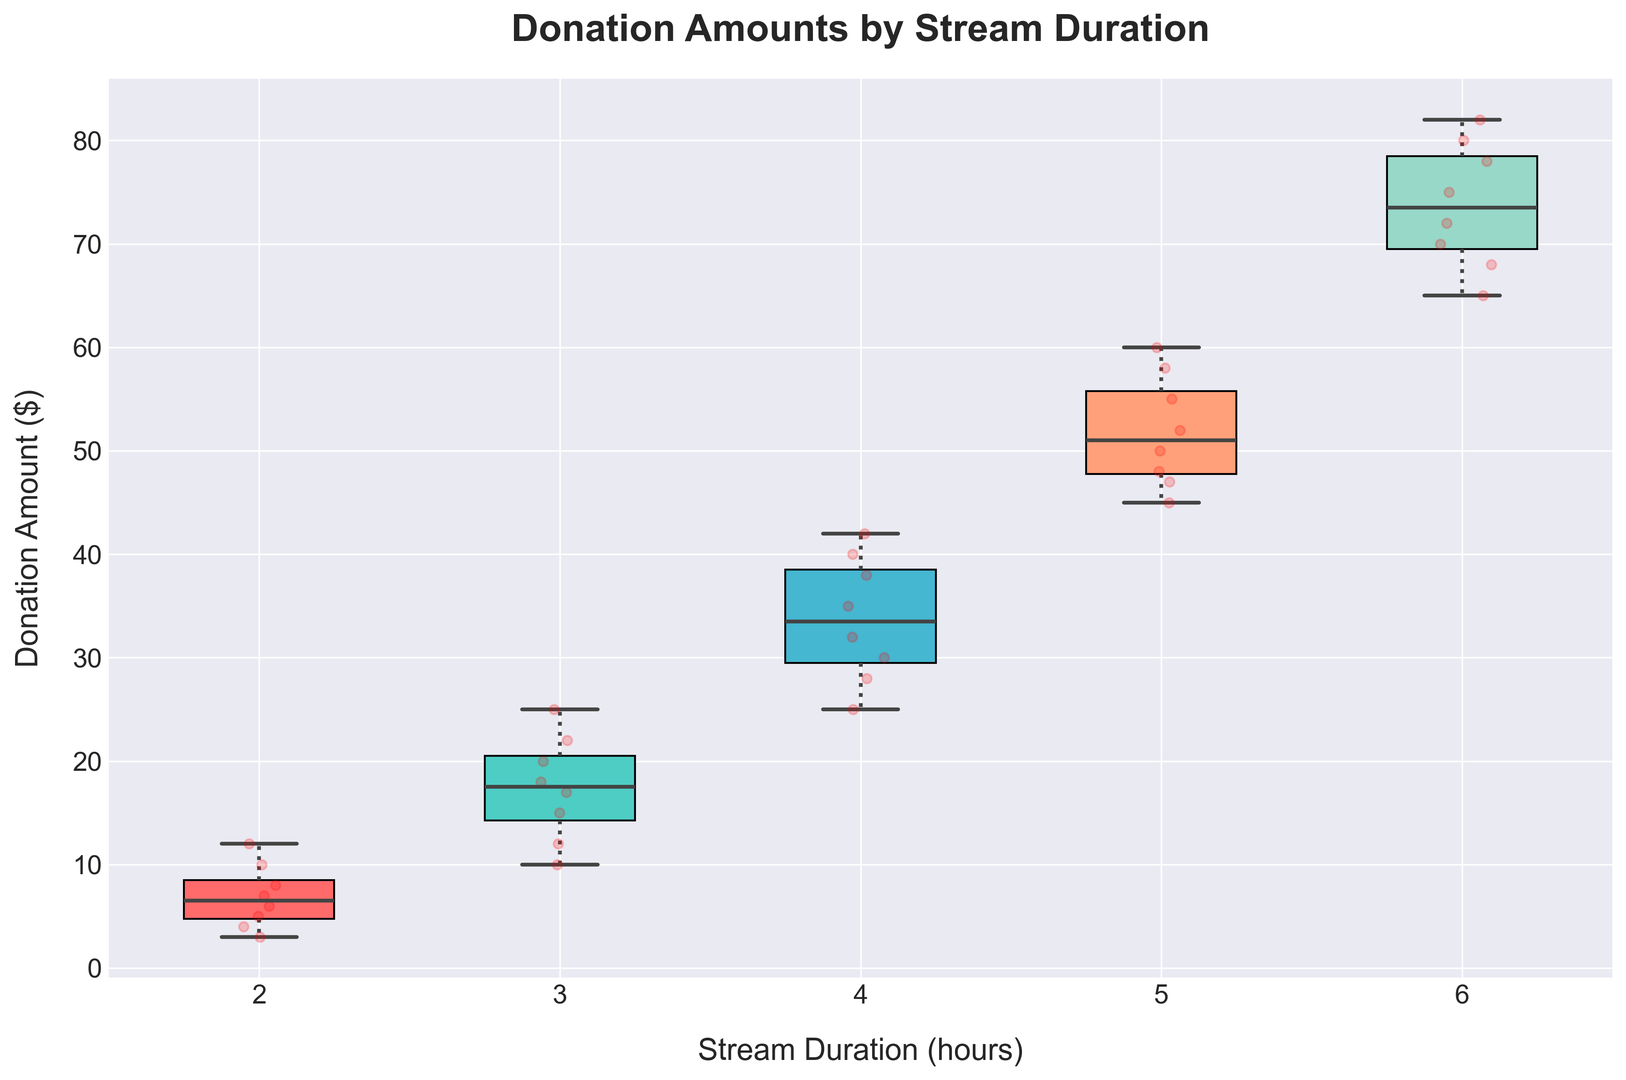What's the median donation amount for 4-hour streams? To find the median, locate the middle value when the donation amounts are arranged in ascending order. For 4-hour streams, the donations are 25, 28, 30, 32, 35, 38, 40, 42. The middle values are 32 and 35, so the median is (32 + 35) / 2 = 33.5.
Answer: 33.5 Which stream duration has the highest maximum donation amount? Examine the upper whisker of each box plot to identify the maximum donation amount for each stream duration. The 6-hour stream duration has the highest maximum donation amount, which is 82.
Answer: 6-hour What is the range of donation amounts for 3-hour streams? The range is the difference between the maximum and minimum values. For 3-hour streams, the donations range from 10 to 25. The range is 25 - 10 = 15.
Answer: 15 By how much does the median donation amount increase from 3-hour to 5-hour streams? Determine the medians for both durations by identifying the middle values. The median for 3-hour streams is 17.5, and for 5-hour streams, it is 51. The increase is 51 - 17.5 = 33.5.
Answer: 33.5 What is the color of the box representing 5-hour streams? Look for the visual attribute of color for the 5-hour box. The box representing 5-hour streams is orange.
Answer: orange Which stream duration has the smallest interquartile range (IQR)? Calculate the IQR by subtracting the first quartile (Q1) from the third quartile (Q3) for each stream duration. The 2-hour streams have the smallest IQR.
Answer: 2-hour How does the median donation for 2-hour streams compare to the 4-hour streams? Compare the heights of the medians. The median donation for 2-hour streams is lower than that of the 4-hour streams, as it lies below the 4-hour median.
Answer: lower What trend can you observe about the median donation amount as the stream duration increases? Observe the positions of the medians across increasing stream durations. The median donation amount generally increases with stream duration.
Answer: increases Which stream duration has the highest variability in donation amounts? Identify the stream duration with the widest spread, as shown by the length of the whiskers and the presence of outliers. The 6-hour stream duration has the highest variability.
Answer: 6-hour What is the middle 50% range of donations for 2-hour streams? Find the first quartile (Q1) and third quartile (Q3) for 2-hour streams, which are 4 and 9. The middle 50% range is from 4 to 9.
Answer: 4 to 9 